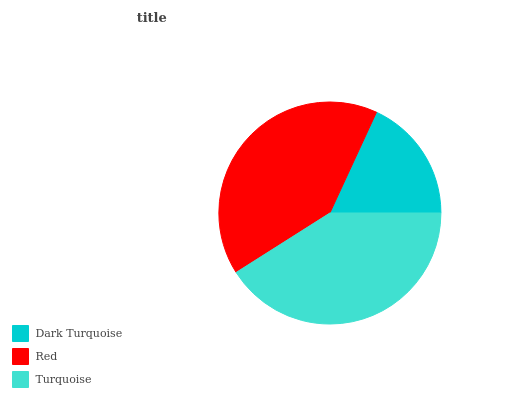Is Dark Turquoise the minimum?
Answer yes or no. Yes. Is Turquoise the maximum?
Answer yes or no. Yes. Is Red the minimum?
Answer yes or no. No. Is Red the maximum?
Answer yes or no. No. Is Red greater than Dark Turquoise?
Answer yes or no. Yes. Is Dark Turquoise less than Red?
Answer yes or no. Yes. Is Dark Turquoise greater than Red?
Answer yes or no. No. Is Red less than Dark Turquoise?
Answer yes or no. No. Is Red the high median?
Answer yes or no. Yes. Is Red the low median?
Answer yes or no. Yes. Is Turquoise the high median?
Answer yes or no. No. Is Dark Turquoise the low median?
Answer yes or no. No. 